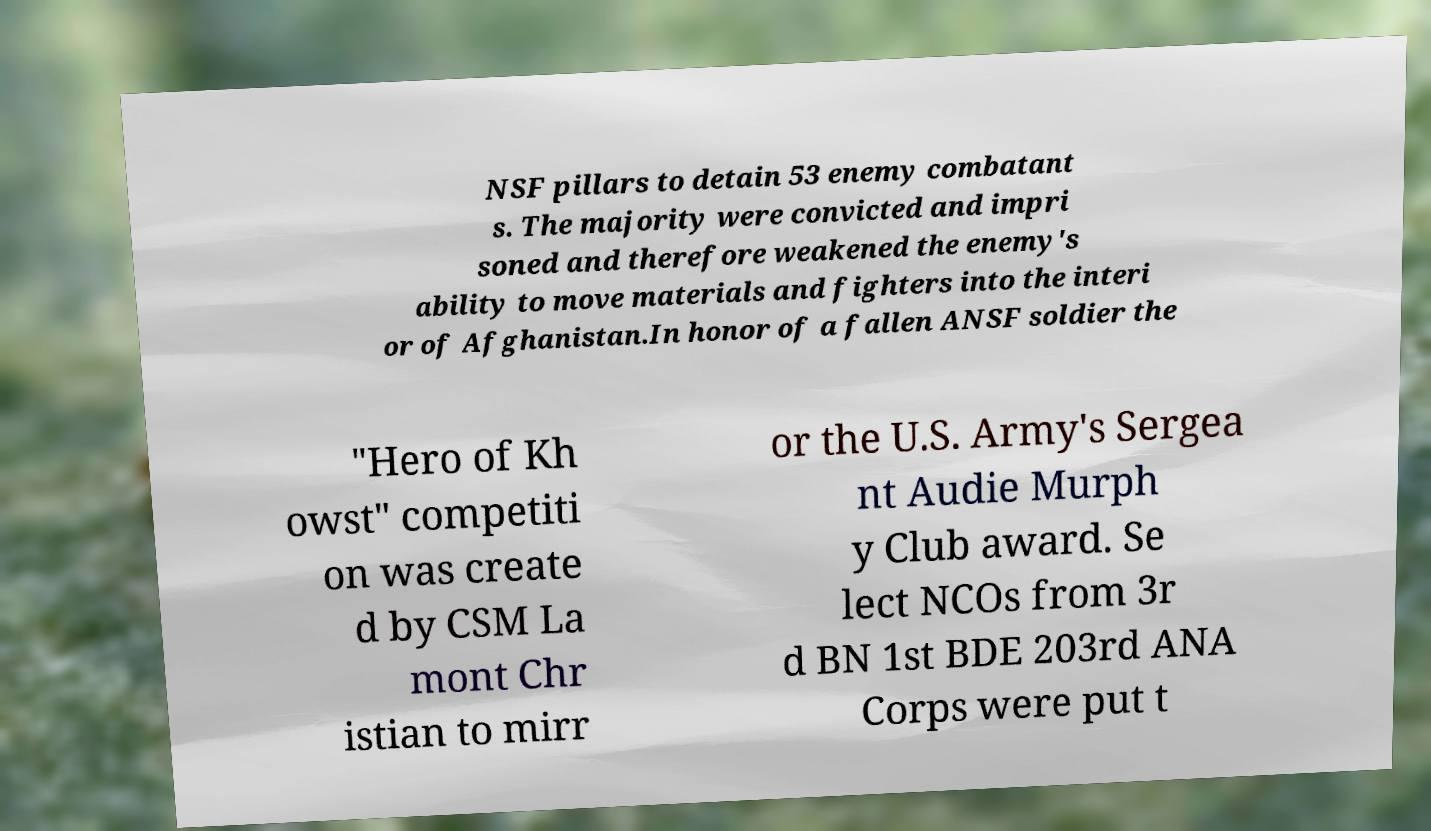Could you extract and type out the text from this image? NSF pillars to detain 53 enemy combatant s. The majority were convicted and impri soned and therefore weakened the enemy's ability to move materials and fighters into the interi or of Afghanistan.In honor of a fallen ANSF soldier the "Hero of Kh owst" competiti on was create d by CSM La mont Chr istian to mirr or the U.S. Army's Sergea nt Audie Murph y Club award. Se lect NCOs from 3r d BN 1st BDE 203rd ANA Corps were put t 